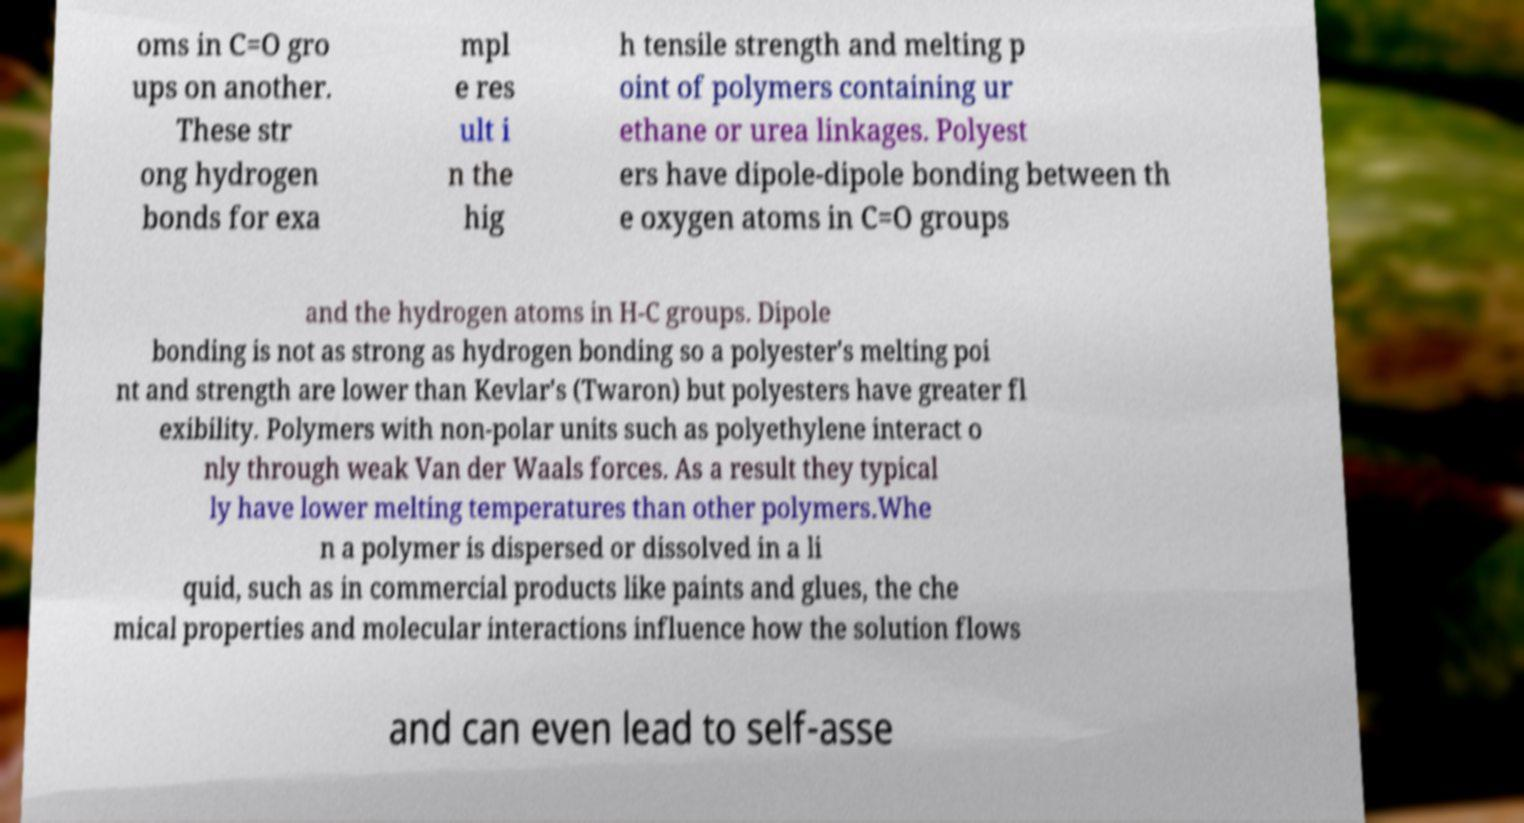Can you read and provide the text displayed in the image?This photo seems to have some interesting text. Can you extract and type it out for me? oms in C=O gro ups on another. These str ong hydrogen bonds for exa mpl e res ult i n the hig h tensile strength and melting p oint of polymers containing ur ethane or urea linkages. Polyest ers have dipole-dipole bonding between th e oxygen atoms in C=O groups and the hydrogen atoms in H-C groups. Dipole bonding is not as strong as hydrogen bonding so a polyester's melting poi nt and strength are lower than Kevlar's (Twaron) but polyesters have greater fl exibility. Polymers with non-polar units such as polyethylene interact o nly through weak Van der Waals forces. As a result they typical ly have lower melting temperatures than other polymers.Whe n a polymer is dispersed or dissolved in a li quid, such as in commercial products like paints and glues, the che mical properties and molecular interactions influence how the solution flows and can even lead to self-asse 